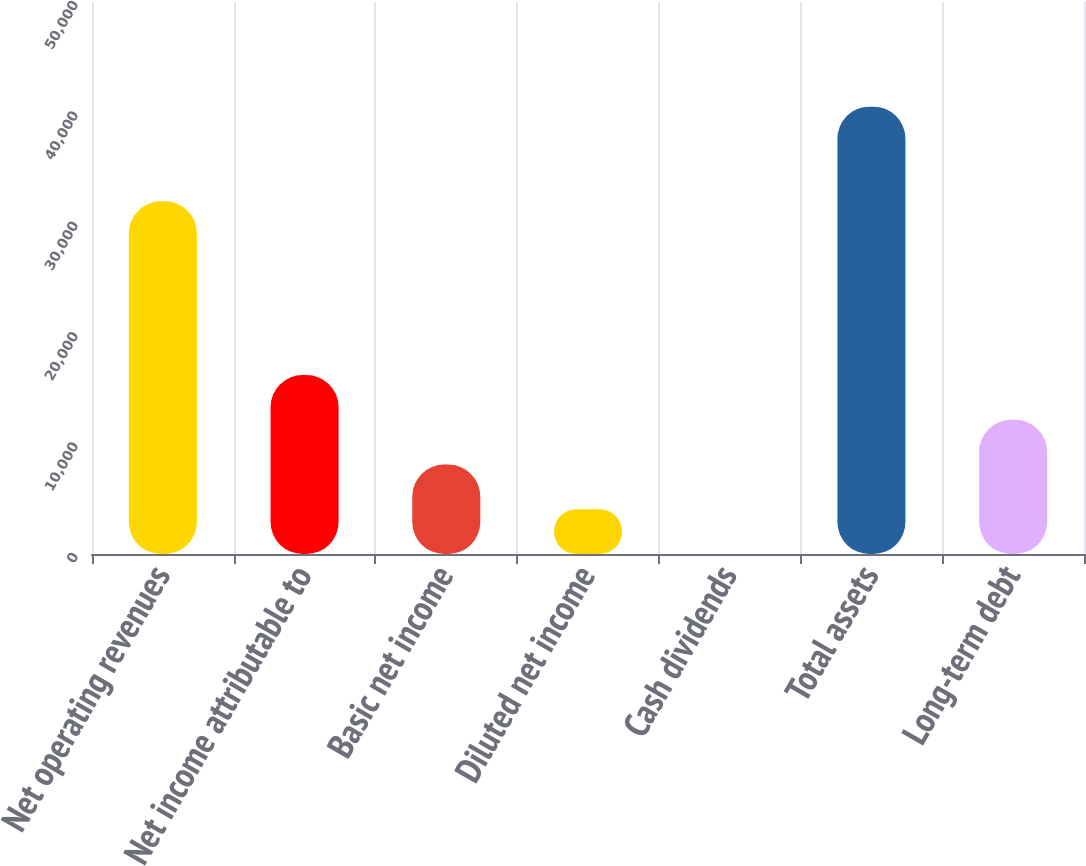Convert chart to OTSL. <chart><loc_0><loc_0><loc_500><loc_500><bar_chart><fcel>Net operating revenues<fcel>Net income attributable to<fcel>Basic net income<fcel>Diluted net income<fcel>Cash dividends<fcel>Total assets<fcel>Long-term debt<nl><fcel>31944<fcel>16208<fcel>8104.4<fcel>4052.58<fcel>0.76<fcel>40519<fcel>12156.2<nl></chart> 